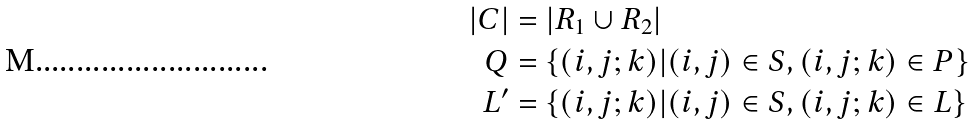Convert formula to latex. <formula><loc_0><loc_0><loc_500><loc_500>\left | C \right | & = \left | R _ { 1 } \cup R _ { 2 } \right | \\ Q & = \{ ( i , j ; k ) | ( i , j ) \in S , ( i , j ; k ) \in P \} \\ L ^ { \prime } & = \{ ( i , j ; k ) | ( i , j ) \in S , ( i , j ; k ) \in L \}</formula> 